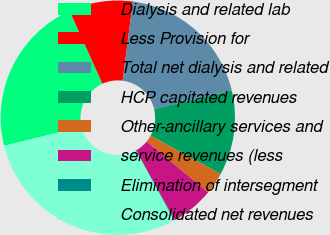<chart> <loc_0><loc_0><loc_500><loc_500><pie_chart><fcel>Dialysis and related lab<fcel>Less Provision for<fcel>Total net dialysis and related<fcel>HCP capitated revenues<fcel>Other-ancillary services and<fcel>service revenues (less<fcel>Elimination of intersegment<fcel>Consolidated net revenues<nl><fcel>22.11%<fcel>8.81%<fcel>19.21%<fcel>11.71%<fcel>3.02%<fcel>5.92%<fcel>0.12%<fcel>29.1%<nl></chart> 